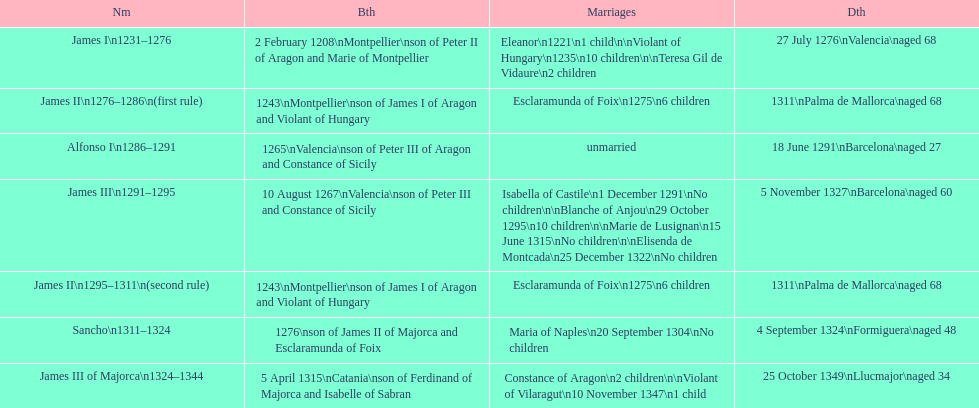Who came to power after the rule of james iii? James II. 